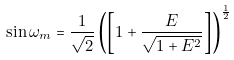Convert formula to latex. <formula><loc_0><loc_0><loc_500><loc_500>\sin \omega _ { m } = \frac { 1 } { \sqrt { 2 } } \left ( \left [ 1 + \frac { E } { \sqrt { 1 + E ^ { 2 } } } \right ] \right ) ^ { \frac { 1 } { 2 } }</formula> 